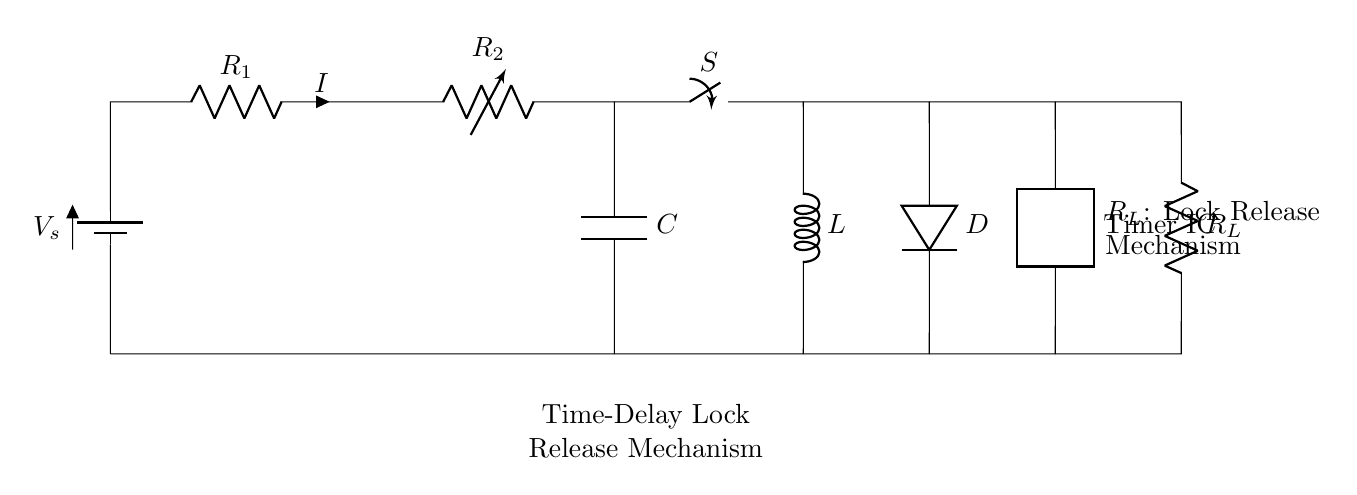What is the type of this circuit? The circuit is a series circuit because all components are connected end-to-end, providing a single path for current to flow.
Answer: Series What component provides the time delay in this circuit? The Timer IC is responsible for controlling the time delay before the lock release mechanism activates.
Answer: Timer IC How many resistors are present in the circuit? There are two resistors, R1 and R_L, visible in the circuit diagram.
Answer: Two What is the role of the switch S? The switch S is used to control the flow of current in the circuit, impacting the operation of the lock release mechanism.
Answer: Control current What is the purpose of the capacitor C in the circuit? The capacitor C is used to store electrical energy and release it over time to create a time delay for the lock release.
Answer: Time delay What happens if the Timer IC is not functioning? If the Timer IC fails, the time delay mechanism would not work, potentially keeping the lock in a locked state indefinitely.
Answer: Lock remains locked What is the current flowing through R1 represented as? The current flowing through R1 is represented by the symbol I, indicating the flow of electricity in the circuit.
Answer: I 